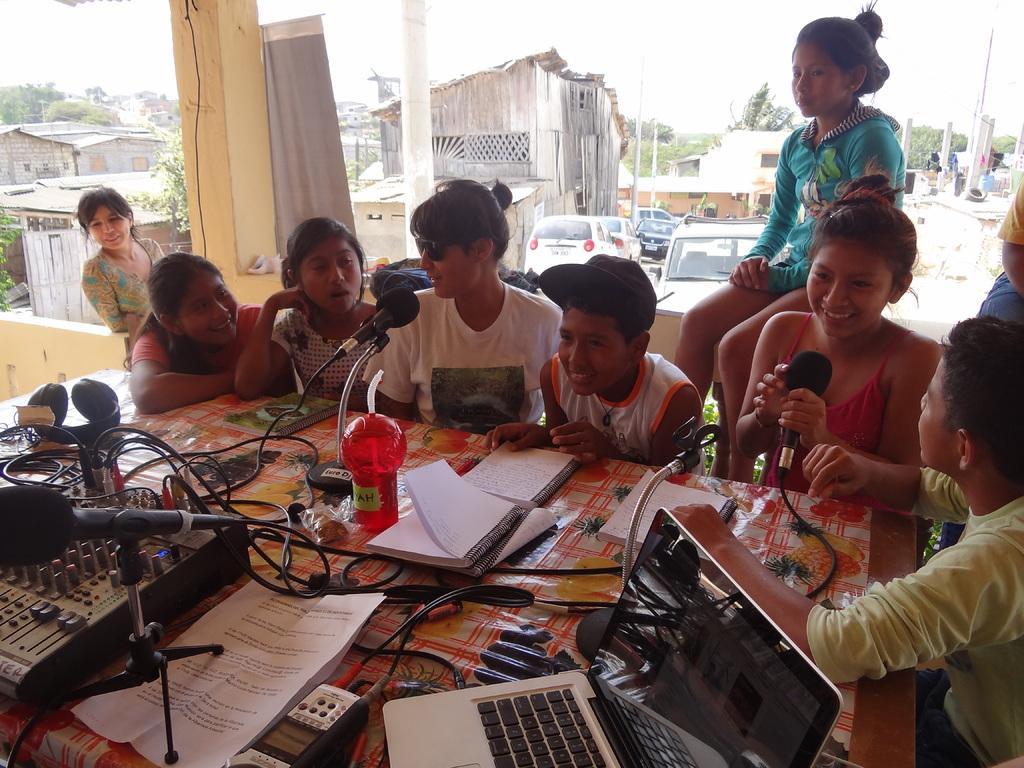How would you summarize this image in a sentence or two? In this image on the foreground there is a table. On the table there are books, papers, cables, laptops, mics and few things are there. Around the table few people are sitting. Here a lady is sitting on the wall. In the background there are buildings, trees, vehicles, poles are there. 